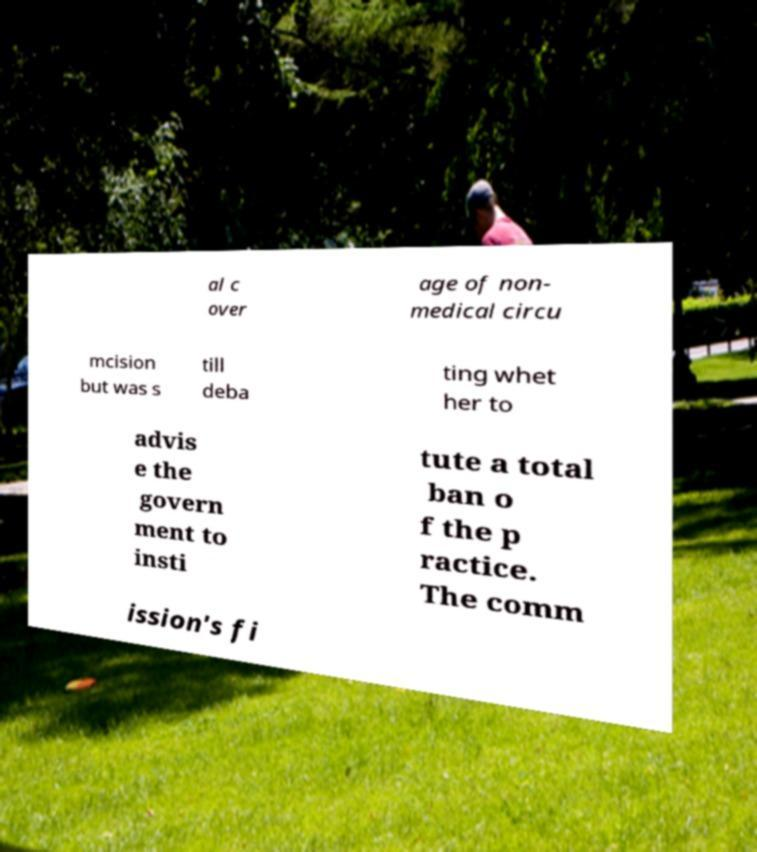Can you accurately transcribe the text from the provided image for me? al c over age of non- medical circu mcision but was s till deba ting whet her to advis e the govern ment to insti tute a total ban o f the p ractice. The comm ission's fi 